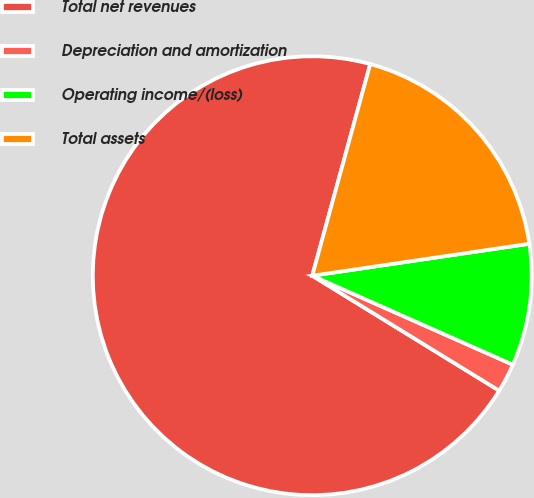Convert chart to OTSL. <chart><loc_0><loc_0><loc_500><loc_500><pie_chart><fcel>Total net revenues<fcel>Depreciation and amortization<fcel>Operating income/(loss)<fcel>Total assets<nl><fcel>70.49%<fcel>2.13%<fcel>8.97%<fcel>18.42%<nl></chart> 